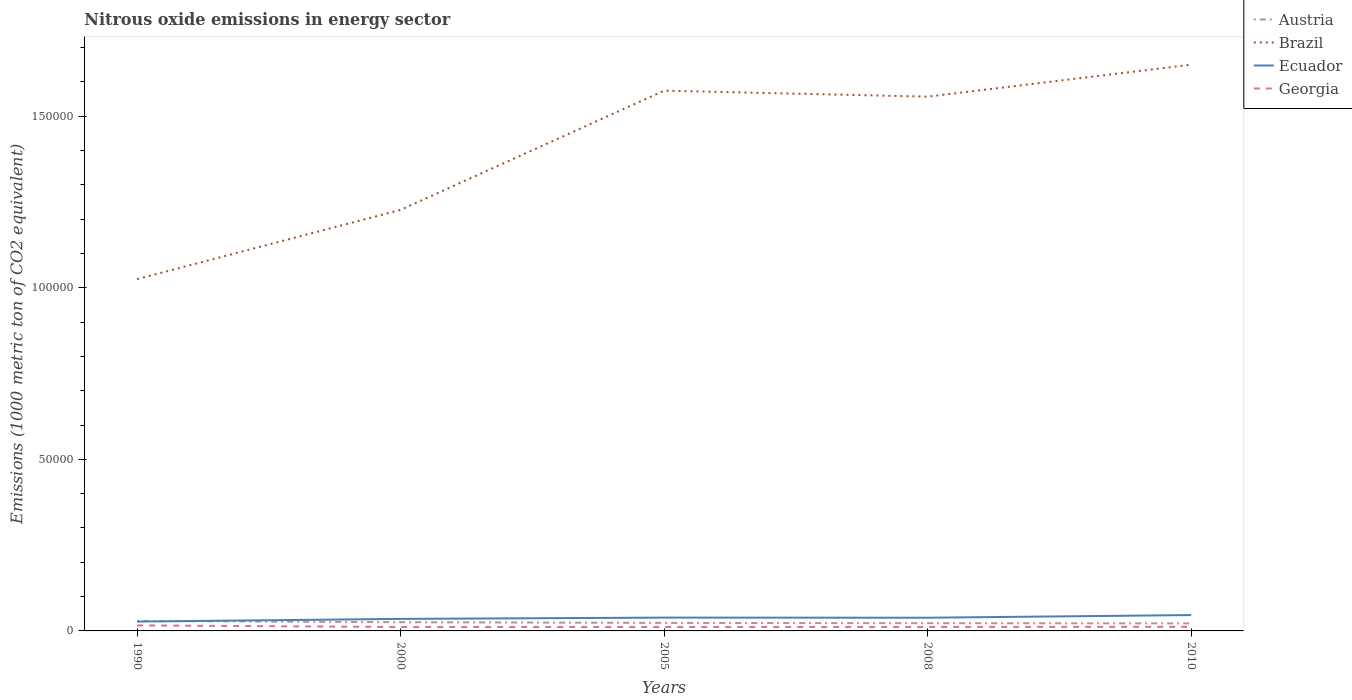Does the line corresponding to Brazil intersect with the line corresponding to Ecuador?
Give a very brief answer. No. Across all years, what is the maximum amount of nitrous oxide emitted in Georgia?
Your answer should be compact. 1137.6. What is the total amount of nitrous oxide emitted in Brazil in the graph?
Your answer should be compact. -3.30e+04. What is the difference between the highest and the second highest amount of nitrous oxide emitted in Ecuador?
Give a very brief answer. 1902.1. What is the difference between the highest and the lowest amount of nitrous oxide emitted in Austria?
Provide a short and direct response. 2. Is the amount of nitrous oxide emitted in Ecuador strictly greater than the amount of nitrous oxide emitted in Georgia over the years?
Keep it short and to the point. No. What is the title of the graph?
Offer a very short reply. Nitrous oxide emissions in energy sector. Does "Zimbabwe" appear as one of the legend labels in the graph?
Your answer should be compact. No. What is the label or title of the Y-axis?
Your response must be concise. Emissions (1000 metric ton of CO2 equivalent). What is the Emissions (1000 metric ton of CO2 equivalent) in Austria in 1990?
Your answer should be very brief. 2904.8. What is the Emissions (1000 metric ton of CO2 equivalent) in Brazil in 1990?
Your response must be concise. 1.03e+05. What is the Emissions (1000 metric ton of CO2 equivalent) of Ecuador in 1990?
Provide a short and direct response. 2718.5. What is the Emissions (1000 metric ton of CO2 equivalent) of Georgia in 1990?
Offer a terse response. 1613.4. What is the Emissions (1000 metric ton of CO2 equivalent) in Austria in 2000?
Your response must be concise. 2543.3. What is the Emissions (1000 metric ton of CO2 equivalent) of Brazil in 2000?
Keep it short and to the point. 1.23e+05. What is the Emissions (1000 metric ton of CO2 equivalent) in Ecuador in 2000?
Keep it short and to the point. 3508.3. What is the Emissions (1000 metric ton of CO2 equivalent) in Georgia in 2000?
Offer a very short reply. 1137.6. What is the Emissions (1000 metric ton of CO2 equivalent) of Austria in 2005?
Offer a very short reply. 2335.7. What is the Emissions (1000 metric ton of CO2 equivalent) in Brazil in 2005?
Make the answer very short. 1.57e+05. What is the Emissions (1000 metric ton of CO2 equivalent) of Ecuador in 2005?
Your response must be concise. 3878.5. What is the Emissions (1000 metric ton of CO2 equivalent) of Georgia in 2005?
Give a very brief answer. 1148.6. What is the Emissions (1000 metric ton of CO2 equivalent) of Austria in 2008?
Provide a short and direct response. 2257.3. What is the Emissions (1000 metric ton of CO2 equivalent) of Brazil in 2008?
Provide a succinct answer. 1.56e+05. What is the Emissions (1000 metric ton of CO2 equivalent) of Ecuador in 2008?
Your answer should be compact. 3846. What is the Emissions (1000 metric ton of CO2 equivalent) of Georgia in 2008?
Offer a very short reply. 1158.8. What is the Emissions (1000 metric ton of CO2 equivalent) in Austria in 2010?
Make the answer very short. 2192.3. What is the Emissions (1000 metric ton of CO2 equivalent) in Brazil in 2010?
Your answer should be very brief. 1.65e+05. What is the Emissions (1000 metric ton of CO2 equivalent) in Ecuador in 2010?
Your answer should be compact. 4620.6. What is the Emissions (1000 metric ton of CO2 equivalent) in Georgia in 2010?
Ensure brevity in your answer.  1195.6. Across all years, what is the maximum Emissions (1000 metric ton of CO2 equivalent) of Austria?
Offer a very short reply. 2904.8. Across all years, what is the maximum Emissions (1000 metric ton of CO2 equivalent) of Brazil?
Ensure brevity in your answer.  1.65e+05. Across all years, what is the maximum Emissions (1000 metric ton of CO2 equivalent) of Ecuador?
Make the answer very short. 4620.6. Across all years, what is the maximum Emissions (1000 metric ton of CO2 equivalent) in Georgia?
Provide a succinct answer. 1613.4. Across all years, what is the minimum Emissions (1000 metric ton of CO2 equivalent) of Austria?
Your answer should be compact. 2192.3. Across all years, what is the minimum Emissions (1000 metric ton of CO2 equivalent) of Brazil?
Give a very brief answer. 1.03e+05. Across all years, what is the minimum Emissions (1000 metric ton of CO2 equivalent) in Ecuador?
Make the answer very short. 2718.5. Across all years, what is the minimum Emissions (1000 metric ton of CO2 equivalent) of Georgia?
Make the answer very short. 1137.6. What is the total Emissions (1000 metric ton of CO2 equivalent) in Austria in the graph?
Provide a succinct answer. 1.22e+04. What is the total Emissions (1000 metric ton of CO2 equivalent) in Brazil in the graph?
Ensure brevity in your answer.  7.03e+05. What is the total Emissions (1000 metric ton of CO2 equivalent) of Ecuador in the graph?
Ensure brevity in your answer.  1.86e+04. What is the total Emissions (1000 metric ton of CO2 equivalent) of Georgia in the graph?
Offer a terse response. 6254. What is the difference between the Emissions (1000 metric ton of CO2 equivalent) in Austria in 1990 and that in 2000?
Keep it short and to the point. 361.5. What is the difference between the Emissions (1000 metric ton of CO2 equivalent) in Brazil in 1990 and that in 2000?
Your answer should be very brief. -2.02e+04. What is the difference between the Emissions (1000 metric ton of CO2 equivalent) in Ecuador in 1990 and that in 2000?
Keep it short and to the point. -789.8. What is the difference between the Emissions (1000 metric ton of CO2 equivalent) in Georgia in 1990 and that in 2000?
Offer a very short reply. 475.8. What is the difference between the Emissions (1000 metric ton of CO2 equivalent) in Austria in 1990 and that in 2005?
Your answer should be compact. 569.1. What is the difference between the Emissions (1000 metric ton of CO2 equivalent) in Brazil in 1990 and that in 2005?
Your response must be concise. -5.49e+04. What is the difference between the Emissions (1000 metric ton of CO2 equivalent) in Ecuador in 1990 and that in 2005?
Your answer should be very brief. -1160. What is the difference between the Emissions (1000 metric ton of CO2 equivalent) of Georgia in 1990 and that in 2005?
Ensure brevity in your answer.  464.8. What is the difference between the Emissions (1000 metric ton of CO2 equivalent) of Austria in 1990 and that in 2008?
Provide a succinct answer. 647.5. What is the difference between the Emissions (1000 metric ton of CO2 equivalent) of Brazil in 1990 and that in 2008?
Your answer should be very brief. -5.32e+04. What is the difference between the Emissions (1000 metric ton of CO2 equivalent) in Ecuador in 1990 and that in 2008?
Provide a short and direct response. -1127.5. What is the difference between the Emissions (1000 metric ton of CO2 equivalent) of Georgia in 1990 and that in 2008?
Ensure brevity in your answer.  454.6. What is the difference between the Emissions (1000 metric ton of CO2 equivalent) in Austria in 1990 and that in 2010?
Offer a very short reply. 712.5. What is the difference between the Emissions (1000 metric ton of CO2 equivalent) in Brazil in 1990 and that in 2010?
Offer a very short reply. -6.25e+04. What is the difference between the Emissions (1000 metric ton of CO2 equivalent) in Ecuador in 1990 and that in 2010?
Provide a succinct answer. -1902.1. What is the difference between the Emissions (1000 metric ton of CO2 equivalent) in Georgia in 1990 and that in 2010?
Make the answer very short. 417.8. What is the difference between the Emissions (1000 metric ton of CO2 equivalent) in Austria in 2000 and that in 2005?
Your answer should be compact. 207.6. What is the difference between the Emissions (1000 metric ton of CO2 equivalent) in Brazil in 2000 and that in 2005?
Your response must be concise. -3.47e+04. What is the difference between the Emissions (1000 metric ton of CO2 equivalent) in Ecuador in 2000 and that in 2005?
Offer a very short reply. -370.2. What is the difference between the Emissions (1000 metric ton of CO2 equivalent) of Austria in 2000 and that in 2008?
Offer a very short reply. 286. What is the difference between the Emissions (1000 metric ton of CO2 equivalent) of Brazil in 2000 and that in 2008?
Offer a very short reply. -3.30e+04. What is the difference between the Emissions (1000 metric ton of CO2 equivalent) of Ecuador in 2000 and that in 2008?
Provide a short and direct response. -337.7. What is the difference between the Emissions (1000 metric ton of CO2 equivalent) of Georgia in 2000 and that in 2008?
Offer a terse response. -21.2. What is the difference between the Emissions (1000 metric ton of CO2 equivalent) of Austria in 2000 and that in 2010?
Your answer should be compact. 351. What is the difference between the Emissions (1000 metric ton of CO2 equivalent) of Brazil in 2000 and that in 2010?
Ensure brevity in your answer.  -4.23e+04. What is the difference between the Emissions (1000 metric ton of CO2 equivalent) of Ecuador in 2000 and that in 2010?
Your answer should be very brief. -1112.3. What is the difference between the Emissions (1000 metric ton of CO2 equivalent) of Georgia in 2000 and that in 2010?
Your answer should be compact. -58. What is the difference between the Emissions (1000 metric ton of CO2 equivalent) of Austria in 2005 and that in 2008?
Provide a succinct answer. 78.4. What is the difference between the Emissions (1000 metric ton of CO2 equivalent) in Brazil in 2005 and that in 2008?
Make the answer very short. 1744.8. What is the difference between the Emissions (1000 metric ton of CO2 equivalent) in Ecuador in 2005 and that in 2008?
Make the answer very short. 32.5. What is the difference between the Emissions (1000 metric ton of CO2 equivalent) of Georgia in 2005 and that in 2008?
Ensure brevity in your answer.  -10.2. What is the difference between the Emissions (1000 metric ton of CO2 equivalent) in Austria in 2005 and that in 2010?
Offer a terse response. 143.4. What is the difference between the Emissions (1000 metric ton of CO2 equivalent) of Brazil in 2005 and that in 2010?
Ensure brevity in your answer.  -7569.5. What is the difference between the Emissions (1000 metric ton of CO2 equivalent) in Ecuador in 2005 and that in 2010?
Offer a very short reply. -742.1. What is the difference between the Emissions (1000 metric ton of CO2 equivalent) of Georgia in 2005 and that in 2010?
Your answer should be very brief. -47. What is the difference between the Emissions (1000 metric ton of CO2 equivalent) in Austria in 2008 and that in 2010?
Give a very brief answer. 65. What is the difference between the Emissions (1000 metric ton of CO2 equivalent) in Brazil in 2008 and that in 2010?
Keep it short and to the point. -9314.3. What is the difference between the Emissions (1000 metric ton of CO2 equivalent) of Ecuador in 2008 and that in 2010?
Give a very brief answer. -774.6. What is the difference between the Emissions (1000 metric ton of CO2 equivalent) of Georgia in 2008 and that in 2010?
Your answer should be very brief. -36.8. What is the difference between the Emissions (1000 metric ton of CO2 equivalent) of Austria in 1990 and the Emissions (1000 metric ton of CO2 equivalent) of Brazil in 2000?
Give a very brief answer. -1.20e+05. What is the difference between the Emissions (1000 metric ton of CO2 equivalent) of Austria in 1990 and the Emissions (1000 metric ton of CO2 equivalent) of Ecuador in 2000?
Offer a terse response. -603.5. What is the difference between the Emissions (1000 metric ton of CO2 equivalent) of Austria in 1990 and the Emissions (1000 metric ton of CO2 equivalent) of Georgia in 2000?
Make the answer very short. 1767.2. What is the difference between the Emissions (1000 metric ton of CO2 equivalent) in Brazil in 1990 and the Emissions (1000 metric ton of CO2 equivalent) in Ecuador in 2000?
Ensure brevity in your answer.  9.90e+04. What is the difference between the Emissions (1000 metric ton of CO2 equivalent) of Brazil in 1990 and the Emissions (1000 metric ton of CO2 equivalent) of Georgia in 2000?
Your answer should be compact. 1.01e+05. What is the difference between the Emissions (1000 metric ton of CO2 equivalent) in Ecuador in 1990 and the Emissions (1000 metric ton of CO2 equivalent) in Georgia in 2000?
Make the answer very short. 1580.9. What is the difference between the Emissions (1000 metric ton of CO2 equivalent) of Austria in 1990 and the Emissions (1000 metric ton of CO2 equivalent) of Brazil in 2005?
Offer a terse response. -1.55e+05. What is the difference between the Emissions (1000 metric ton of CO2 equivalent) in Austria in 1990 and the Emissions (1000 metric ton of CO2 equivalent) in Ecuador in 2005?
Provide a succinct answer. -973.7. What is the difference between the Emissions (1000 metric ton of CO2 equivalent) in Austria in 1990 and the Emissions (1000 metric ton of CO2 equivalent) in Georgia in 2005?
Give a very brief answer. 1756.2. What is the difference between the Emissions (1000 metric ton of CO2 equivalent) of Brazil in 1990 and the Emissions (1000 metric ton of CO2 equivalent) of Ecuador in 2005?
Offer a very short reply. 9.87e+04. What is the difference between the Emissions (1000 metric ton of CO2 equivalent) of Brazil in 1990 and the Emissions (1000 metric ton of CO2 equivalent) of Georgia in 2005?
Your answer should be compact. 1.01e+05. What is the difference between the Emissions (1000 metric ton of CO2 equivalent) of Ecuador in 1990 and the Emissions (1000 metric ton of CO2 equivalent) of Georgia in 2005?
Keep it short and to the point. 1569.9. What is the difference between the Emissions (1000 metric ton of CO2 equivalent) of Austria in 1990 and the Emissions (1000 metric ton of CO2 equivalent) of Brazil in 2008?
Give a very brief answer. -1.53e+05. What is the difference between the Emissions (1000 metric ton of CO2 equivalent) of Austria in 1990 and the Emissions (1000 metric ton of CO2 equivalent) of Ecuador in 2008?
Provide a succinct answer. -941.2. What is the difference between the Emissions (1000 metric ton of CO2 equivalent) of Austria in 1990 and the Emissions (1000 metric ton of CO2 equivalent) of Georgia in 2008?
Provide a short and direct response. 1746. What is the difference between the Emissions (1000 metric ton of CO2 equivalent) of Brazil in 1990 and the Emissions (1000 metric ton of CO2 equivalent) of Ecuador in 2008?
Your answer should be compact. 9.87e+04. What is the difference between the Emissions (1000 metric ton of CO2 equivalent) in Brazil in 1990 and the Emissions (1000 metric ton of CO2 equivalent) in Georgia in 2008?
Provide a short and direct response. 1.01e+05. What is the difference between the Emissions (1000 metric ton of CO2 equivalent) of Ecuador in 1990 and the Emissions (1000 metric ton of CO2 equivalent) of Georgia in 2008?
Offer a very short reply. 1559.7. What is the difference between the Emissions (1000 metric ton of CO2 equivalent) in Austria in 1990 and the Emissions (1000 metric ton of CO2 equivalent) in Brazil in 2010?
Provide a short and direct response. -1.62e+05. What is the difference between the Emissions (1000 metric ton of CO2 equivalent) of Austria in 1990 and the Emissions (1000 metric ton of CO2 equivalent) of Ecuador in 2010?
Your response must be concise. -1715.8. What is the difference between the Emissions (1000 metric ton of CO2 equivalent) in Austria in 1990 and the Emissions (1000 metric ton of CO2 equivalent) in Georgia in 2010?
Offer a terse response. 1709.2. What is the difference between the Emissions (1000 metric ton of CO2 equivalent) of Brazil in 1990 and the Emissions (1000 metric ton of CO2 equivalent) of Ecuador in 2010?
Ensure brevity in your answer.  9.79e+04. What is the difference between the Emissions (1000 metric ton of CO2 equivalent) in Brazil in 1990 and the Emissions (1000 metric ton of CO2 equivalent) in Georgia in 2010?
Offer a terse response. 1.01e+05. What is the difference between the Emissions (1000 metric ton of CO2 equivalent) in Ecuador in 1990 and the Emissions (1000 metric ton of CO2 equivalent) in Georgia in 2010?
Provide a succinct answer. 1522.9. What is the difference between the Emissions (1000 metric ton of CO2 equivalent) of Austria in 2000 and the Emissions (1000 metric ton of CO2 equivalent) of Brazil in 2005?
Your response must be concise. -1.55e+05. What is the difference between the Emissions (1000 metric ton of CO2 equivalent) of Austria in 2000 and the Emissions (1000 metric ton of CO2 equivalent) of Ecuador in 2005?
Your response must be concise. -1335.2. What is the difference between the Emissions (1000 metric ton of CO2 equivalent) of Austria in 2000 and the Emissions (1000 metric ton of CO2 equivalent) of Georgia in 2005?
Provide a short and direct response. 1394.7. What is the difference between the Emissions (1000 metric ton of CO2 equivalent) of Brazil in 2000 and the Emissions (1000 metric ton of CO2 equivalent) of Ecuador in 2005?
Your answer should be very brief. 1.19e+05. What is the difference between the Emissions (1000 metric ton of CO2 equivalent) in Brazil in 2000 and the Emissions (1000 metric ton of CO2 equivalent) in Georgia in 2005?
Your answer should be compact. 1.22e+05. What is the difference between the Emissions (1000 metric ton of CO2 equivalent) in Ecuador in 2000 and the Emissions (1000 metric ton of CO2 equivalent) in Georgia in 2005?
Your answer should be very brief. 2359.7. What is the difference between the Emissions (1000 metric ton of CO2 equivalent) in Austria in 2000 and the Emissions (1000 metric ton of CO2 equivalent) in Brazil in 2008?
Provide a short and direct response. -1.53e+05. What is the difference between the Emissions (1000 metric ton of CO2 equivalent) in Austria in 2000 and the Emissions (1000 metric ton of CO2 equivalent) in Ecuador in 2008?
Offer a terse response. -1302.7. What is the difference between the Emissions (1000 metric ton of CO2 equivalent) in Austria in 2000 and the Emissions (1000 metric ton of CO2 equivalent) in Georgia in 2008?
Provide a succinct answer. 1384.5. What is the difference between the Emissions (1000 metric ton of CO2 equivalent) of Brazil in 2000 and the Emissions (1000 metric ton of CO2 equivalent) of Ecuador in 2008?
Keep it short and to the point. 1.19e+05. What is the difference between the Emissions (1000 metric ton of CO2 equivalent) of Brazil in 2000 and the Emissions (1000 metric ton of CO2 equivalent) of Georgia in 2008?
Your response must be concise. 1.22e+05. What is the difference between the Emissions (1000 metric ton of CO2 equivalent) of Ecuador in 2000 and the Emissions (1000 metric ton of CO2 equivalent) of Georgia in 2008?
Give a very brief answer. 2349.5. What is the difference between the Emissions (1000 metric ton of CO2 equivalent) of Austria in 2000 and the Emissions (1000 metric ton of CO2 equivalent) of Brazil in 2010?
Offer a terse response. -1.62e+05. What is the difference between the Emissions (1000 metric ton of CO2 equivalent) of Austria in 2000 and the Emissions (1000 metric ton of CO2 equivalent) of Ecuador in 2010?
Give a very brief answer. -2077.3. What is the difference between the Emissions (1000 metric ton of CO2 equivalent) in Austria in 2000 and the Emissions (1000 metric ton of CO2 equivalent) in Georgia in 2010?
Offer a terse response. 1347.7. What is the difference between the Emissions (1000 metric ton of CO2 equivalent) in Brazil in 2000 and the Emissions (1000 metric ton of CO2 equivalent) in Ecuador in 2010?
Ensure brevity in your answer.  1.18e+05. What is the difference between the Emissions (1000 metric ton of CO2 equivalent) in Brazil in 2000 and the Emissions (1000 metric ton of CO2 equivalent) in Georgia in 2010?
Give a very brief answer. 1.22e+05. What is the difference between the Emissions (1000 metric ton of CO2 equivalent) in Ecuador in 2000 and the Emissions (1000 metric ton of CO2 equivalent) in Georgia in 2010?
Give a very brief answer. 2312.7. What is the difference between the Emissions (1000 metric ton of CO2 equivalent) of Austria in 2005 and the Emissions (1000 metric ton of CO2 equivalent) of Brazil in 2008?
Your response must be concise. -1.53e+05. What is the difference between the Emissions (1000 metric ton of CO2 equivalent) in Austria in 2005 and the Emissions (1000 metric ton of CO2 equivalent) in Ecuador in 2008?
Ensure brevity in your answer.  -1510.3. What is the difference between the Emissions (1000 metric ton of CO2 equivalent) of Austria in 2005 and the Emissions (1000 metric ton of CO2 equivalent) of Georgia in 2008?
Your answer should be compact. 1176.9. What is the difference between the Emissions (1000 metric ton of CO2 equivalent) in Brazil in 2005 and the Emissions (1000 metric ton of CO2 equivalent) in Ecuador in 2008?
Give a very brief answer. 1.54e+05. What is the difference between the Emissions (1000 metric ton of CO2 equivalent) in Brazil in 2005 and the Emissions (1000 metric ton of CO2 equivalent) in Georgia in 2008?
Keep it short and to the point. 1.56e+05. What is the difference between the Emissions (1000 metric ton of CO2 equivalent) in Ecuador in 2005 and the Emissions (1000 metric ton of CO2 equivalent) in Georgia in 2008?
Make the answer very short. 2719.7. What is the difference between the Emissions (1000 metric ton of CO2 equivalent) in Austria in 2005 and the Emissions (1000 metric ton of CO2 equivalent) in Brazil in 2010?
Offer a terse response. -1.63e+05. What is the difference between the Emissions (1000 metric ton of CO2 equivalent) in Austria in 2005 and the Emissions (1000 metric ton of CO2 equivalent) in Ecuador in 2010?
Your answer should be compact. -2284.9. What is the difference between the Emissions (1000 metric ton of CO2 equivalent) of Austria in 2005 and the Emissions (1000 metric ton of CO2 equivalent) of Georgia in 2010?
Offer a terse response. 1140.1. What is the difference between the Emissions (1000 metric ton of CO2 equivalent) in Brazil in 2005 and the Emissions (1000 metric ton of CO2 equivalent) in Ecuador in 2010?
Your answer should be very brief. 1.53e+05. What is the difference between the Emissions (1000 metric ton of CO2 equivalent) in Brazil in 2005 and the Emissions (1000 metric ton of CO2 equivalent) in Georgia in 2010?
Give a very brief answer. 1.56e+05. What is the difference between the Emissions (1000 metric ton of CO2 equivalent) in Ecuador in 2005 and the Emissions (1000 metric ton of CO2 equivalent) in Georgia in 2010?
Your answer should be compact. 2682.9. What is the difference between the Emissions (1000 metric ton of CO2 equivalent) in Austria in 2008 and the Emissions (1000 metric ton of CO2 equivalent) in Brazil in 2010?
Provide a succinct answer. -1.63e+05. What is the difference between the Emissions (1000 metric ton of CO2 equivalent) of Austria in 2008 and the Emissions (1000 metric ton of CO2 equivalent) of Ecuador in 2010?
Provide a succinct answer. -2363.3. What is the difference between the Emissions (1000 metric ton of CO2 equivalent) in Austria in 2008 and the Emissions (1000 metric ton of CO2 equivalent) in Georgia in 2010?
Offer a very short reply. 1061.7. What is the difference between the Emissions (1000 metric ton of CO2 equivalent) in Brazil in 2008 and the Emissions (1000 metric ton of CO2 equivalent) in Ecuador in 2010?
Make the answer very short. 1.51e+05. What is the difference between the Emissions (1000 metric ton of CO2 equivalent) in Brazil in 2008 and the Emissions (1000 metric ton of CO2 equivalent) in Georgia in 2010?
Make the answer very short. 1.55e+05. What is the difference between the Emissions (1000 metric ton of CO2 equivalent) of Ecuador in 2008 and the Emissions (1000 metric ton of CO2 equivalent) of Georgia in 2010?
Your answer should be very brief. 2650.4. What is the average Emissions (1000 metric ton of CO2 equivalent) of Austria per year?
Make the answer very short. 2446.68. What is the average Emissions (1000 metric ton of CO2 equivalent) in Brazil per year?
Make the answer very short. 1.41e+05. What is the average Emissions (1000 metric ton of CO2 equivalent) of Ecuador per year?
Ensure brevity in your answer.  3714.38. What is the average Emissions (1000 metric ton of CO2 equivalent) of Georgia per year?
Offer a very short reply. 1250.8. In the year 1990, what is the difference between the Emissions (1000 metric ton of CO2 equivalent) in Austria and Emissions (1000 metric ton of CO2 equivalent) in Brazil?
Offer a terse response. -9.96e+04. In the year 1990, what is the difference between the Emissions (1000 metric ton of CO2 equivalent) in Austria and Emissions (1000 metric ton of CO2 equivalent) in Ecuador?
Your answer should be very brief. 186.3. In the year 1990, what is the difference between the Emissions (1000 metric ton of CO2 equivalent) of Austria and Emissions (1000 metric ton of CO2 equivalent) of Georgia?
Your answer should be compact. 1291.4. In the year 1990, what is the difference between the Emissions (1000 metric ton of CO2 equivalent) of Brazil and Emissions (1000 metric ton of CO2 equivalent) of Ecuador?
Offer a very short reply. 9.98e+04. In the year 1990, what is the difference between the Emissions (1000 metric ton of CO2 equivalent) of Brazil and Emissions (1000 metric ton of CO2 equivalent) of Georgia?
Ensure brevity in your answer.  1.01e+05. In the year 1990, what is the difference between the Emissions (1000 metric ton of CO2 equivalent) in Ecuador and Emissions (1000 metric ton of CO2 equivalent) in Georgia?
Your answer should be compact. 1105.1. In the year 2000, what is the difference between the Emissions (1000 metric ton of CO2 equivalent) of Austria and Emissions (1000 metric ton of CO2 equivalent) of Brazil?
Your answer should be very brief. -1.20e+05. In the year 2000, what is the difference between the Emissions (1000 metric ton of CO2 equivalent) in Austria and Emissions (1000 metric ton of CO2 equivalent) in Ecuador?
Your answer should be compact. -965. In the year 2000, what is the difference between the Emissions (1000 metric ton of CO2 equivalent) of Austria and Emissions (1000 metric ton of CO2 equivalent) of Georgia?
Give a very brief answer. 1405.7. In the year 2000, what is the difference between the Emissions (1000 metric ton of CO2 equivalent) of Brazil and Emissions (1000 metric ton of CO2 equivalent) of Ecuador?
Offer a very short reply. 1.19e+05. In the year 2000, what is the difference between the Emissions (1000 metric ton of CO2 equivalent) in Brazil and Emissions (1000 metric ton of CO2 equivalent) in Georgia?
Your answer should be compact. 1.22e+05. In the year 2000, what is the difference between the Emissions (1000 metric ton of CO2 equivalent) in Ecuador and Emissions (1000 metric ton of CO2 equivalent) in Georgia?
Your answer should be compact. 2370.7. In the year 2005, what is the difference between the Emissions (1000 metric ton of CO2 equivalent) in Austria and Emissions (1000 metric ton of CO2 equivalent) in Brazil?
Give a very brief answer. -1.55e+05. In the year 2005, what is the difference between the Emissions (1000 metric ton of CO2 equivalent) of Austria and Emissions (1000 metric ton of CO2 equivalent) of Ecuador?
Provide a succinct answer. -1542.8. In the year 2005, what is the difference between the Emissions (1000 metric ton of CO2 equivalent) of Austria and Emissions (1000 metric ton of CO2 equivalent) of Georgia?
Your answer should be compact. 1187.1. In the year 2005, what is the difference between the Emissions (1000 metric ton of CO2 equivalent) of Brazil and Emissions (1000 metric ton of CO2 equivalent) of Ecuador?
Offer a very short reply. 1.54e+05. In the year 2005, what is the difference between the Emissions (1000 metric ton of CO2 equivalent) in Brazil and Emissions (1000 metric ton of CO2 equivalent) in Georgia?
Make the answer very short. 1.56e+05. In the year 2005, what is the difference between the Emissions (1000 metric ton of CO2 equivalent) in Ecuador and Emissions (1000 metric ton of CO2 equivalent) in Georgia?
Provide a succinct answer. 2729.9. In the year 2008, what is the difference between the Emissions (1000 metric ton of CO2 equivalent) in Austria and Emissions (1000 metric ton of CO2 equivalent) in Brazil?
Offer a terse response. -1.53e+05. In the year 2008, what is the difference between the Emissions (1000 metric ton of CO2 equivalent) of Austria and Emissions (1000 metric ton of CO2 equivalent) of Ecuador?
Ensure brevity in your answer.  -1588.7. In the year 2008, what is the difference between the Emissions (1000 metric ton of CO2 equivalent) in Austria and Emissions (1000 metric ton of CO2 equivalent) in Georgia?
Keep it short and to the point. 1098.5. In the year 2008, what is the difference between the Emissions (1000 metric ton of CO2 equivalent) in Brazil and Emissions (1000 metric ton of CO2 equivalent) in Ecuador?
Give a very brief answer. 1.52e+05. In the year 2008, what is the difference between the Emissions (1000 metric ton of CO2 equivalent) of Brazil and Emissions (1000 metric ton of CO2 equivalent) of Georgia?
Keep it short and to the point. 1.55e+05. In the year 2008, what is the difference between the Emissions (1000 metric ton of CO2 equivalent) of Ecuador and Emissions (1000 metric ton of CO2 equivalent) of Georgia?
Keep it short and to the point. 2687.2. In the year 2010, what is the difference between the Emissions (1000 metric ton of CO2 equivalent) in Austria and Emissions (1000 metric ton of CO2 equivalent) in Brazil?
Your answer should be compact. -1.63e+05. In the year 2010, what is the difference between the Emissions (1000 metric ton of CO2 equivalent) of Austria and Emissions (1000 metric ton of CO2 equivalent) of Ecuador?
Give a very brief answer. -2428.3. In the year 2010, what is the difference between the Emissions (1000 metric ton of CO2 equivalent) of Austria and Emissions (1000 metric ton of CO2 equivalent) of Georgia?
Offer a terse response. 996.7. In the year 2010, what is the difference between the Emissions (1000 metric ton of CO2 equivalent) of Brazil and Emissions (1000 metric ton of CO2 equivalent) of Ecuador?
Provide a short and direct response. 1.60e+05. In the year 2010, what is the difference between the Emissions (1000 metric ton of CO2 equivalent) in Brazil and Emissions (1000 metric ton of CO2 equivalent) in Georgia?
Make the answer very short. 1.64e+05. In the year 2010, what is the difference between the Emissions (1000 metric ton of CO2 equivalent) in Ecuador and Emissions (1000 metric ton of CO2 equivalent) in Georgia?
Your answer should be very brief. 3425. What is the ratio of the Emissions (1000 metric ton of CO2 equivalent) of Austria in 1990 to that in 2000?
Keep it short and to the point. 1.14. What is the ratio of the Emissions (1000 metric ton of CO2 equivalent) in Brazil in 1990 to that in 2000?
Ensure brevity in your answer.  0.84. What is the ratio of the Emissions (1000 metric ton of CO2 equivalent) of Ecuador in 1990 to that in 2000?
Provide a short and direct response. 0.77. What is the ratio of the Emissions (1000 metric ton of CO2 equivalent) in Georgia in 1990 to that in 2000?
Your response must be concise. 1.42. What is the ratio of the Emissions (1000 metric ton of CO2 equivalent) of Austria in 1990 to that in 2005?
Give a very brief answer. 1.24. What is the ratio of the Emissions (1000 metric ton of CO2 equivalent) in Brazil in 1990 to that in 2005?
Keep it short and to the point. 0.65. What is the ratio of the Emissions (1000 metric ton of CO2 equivalent) of Ecuador in 1990 to that in 2005?
Provide a short and direct response. 0.7. What is the ratio of the Emissions (1000 metric ton of CO2 equivalent) of Georgia in 1990 to that in 2005?
Your answer should be compact. 1.4. What is the ratio of the Emissions (1000 metric ton of CO2 equivalent) of Austria in 1990 to that in 2008?
Your answer should be compact. 1.29. What is the ratio of the Emissions (1000 metric ton of CO2 equivalent) of Brazil in 1990 to that in 2008?
Provide a succinct answer. 0.66. What is the ratio of the Emissions (1000 metric ton of CO2 equivalent) in Ecuador in 1990 to that in 2008?
Provide a short and direct response. 0.71. What is the ratio of the Emissions (1000 metric ton of CO2 equivalent) in Georgia in 1990 to that in 2008?
Your answer should be very brief. 1.39. What is the ratio of the Emissions (1000 metric ton of CO2 equivalent) in Austria in 1990 to that in 2010?
Your response must be concise. 1.32. What is the ratio of the Emissions (1000 metric ton of CO2 equivalent) in Brazil in 1990 to that in 2010?
Your answer should be very brief. 0.62. What is the ratio of the Emissions (1000 metric ton of CO2 equivalent) of Ecuador in 1990 to that in 2010?
Offer a terse response. 0.59. What is the ratio of the Emissions (1000 metric ton of CO2 equivalent) of Georgia in 1990 to that in 2010?
Your answer should be very brief. 1.35. What is the ratio of the Emissions (1000 metric ton of CO2 equivalent) in Austria in 2000 to that in 2005?
Ensure brevity in your answer.  1.09. What is the ratio of the Emissions (1000 metric ton of CO2 equivalent) in Brazil in 2000 to that in 2005?
Offer a terse response. 0.78. What is the ratio of the Emissions (1000 metric ton of CO2 equivalent) in Ecuador in 2000 to that in 2005?
Keep it short and to the point. 0.9. What is the ratio of the Emissions (1000 metric ton of CO2 equivalent) in Austria in 2000 to that in 2008?
Your answer should be very brief. 1.13. What is the ratio of the Emissions (1000 metric ton of CO2 equivalent) of Brazil in 2000 to that in 2008?
Provide a short and direct response. 0.79. What is the ratio of the Emissions (1000 metric ton of CO2 equivalent) in Ecuador in 2000 to that in 2008?
Your response must be concise. 0.91. What is the ratio of the Emissions (1000 metric ton of CO2 equivalent) in Georgia in 2000 to that in 2008?
Give a very brief answer. 0.98. What is the ratio of the Emissions (1000 metric ton of CO2 equivalent) in Austria in 2000 to that in 2010?
Your response must be concise. 1.16. What is the ratio of the Emissions (1000 metric ton of CO2 equivalent) in Brazil in 2000 to that in 2010?
Your answer should be compact. 0.74. What is the ratio of the Emissions (1000 metric ton of CO2 equivalent) of Ecuador in 2000 to that in 2010?
Your answer should be very brief. 0.76. What is the ratio of the Emissions (1000 metric ton of CO2 equivalent) of Georgia in 2000 to that in 2010?
Your answer should be compact. 0.95. What is the ratio of the Emissions (1000 metric ton of CO2 equivalent) in Austria in 2005 to that in 2008?
Keep it short and to the point. 1.03. What is the ratio of the Emissions (1000 metric ton of CO2 equivalent) of Brazil in 2005 to that in 2008?
Your response must be concise. 1.01. What is the ratio of the Emissions (1000 metric ton of CO2 equivalent) in Ecuador in 2005 to that in 2008?
Your response must be concise. 1.01. What is the ratio of the Emissions (1000 metric ton of CO2 equivalent) in Austria in 2005 to that in 2010?
Offer a terse response. 1.07. What is the ratio of the Emissions (1000 metric ton of CO2 equivalent) in Brazil in 2005 to that in 2010?
Offer a terse response. 0.95. What is the ratio of the Emissions (1000 metric ton of CO2 equivalent) in Ecuador in 2005 to that in 2010?
Provide a succinct answer. 0.84. What is the ratio of the Emissions (1000 metric ton of CO2 equivalent) in Georgia in 2005 to that in 2010?
Offer a very short reply. 0.96. What is the ratio of the Emissions (1000 metric ton of CO2 equivalent) of Austria in 2008 to that in 2010?
Your response must be concise. 1.03. What is the ratio of the Emissions (1000 metric ton of CO2 equivalent) of Brazil in 2008 to that in 2010?
Offer a very short reply. 0.94. What is the ratio of the Emissions (1000 metric ton of CO2 equivalent) of Ecuador in 2008 to that in 2010?
Offer a terse response. 0.83. What is the ratio of the Emissions (1000 metric ton of CO2 equivalent) of Georgia in 2008 to that in 2010?
Give a very brief answer. 0.97. What is the difference between the highest and the second highest Emissions (1000 metric ton of CO2 equivalent) in Austria?
Provide a succinct answer. 361.5. What is the difference between the highest and the second highest Emissions (1000 metric ton of CO2 equivalent) in Brazil?
Offer a very short reply. 7569.5. What is the difference between the highest and the second highest Emissions (1000 metric ton of CO2 equivalent) of Ecuador?
Keep it short and to the point. 742.1. What is the difference between the highest and the second highest Emissions (1000 metric ton of CO2 equivalent) in Georgia?
Offer a terse response. 417.8. What is the difference between the highest and the lowest Emissions (1000 metric ton of CO2 equivalent) in Austria?
Provide a short and direct response. 712.5. What is the difference between the highest and the lowest Emissions (1000 metric ton of CO2 equivalent) of Brazil?
Make the answer very short. 6.25e+04. What is the difference between the highest and the lowest Emissions (1000 metric ton of CO2 equivalent) of Ecuador?
Make the answer very short. 1902.1. What is the difference between the highest and the lowest Emissions (1000 metric ton of CO2 equivalent) in Georgia?
Ensure brevity in your answer.  475.8. 